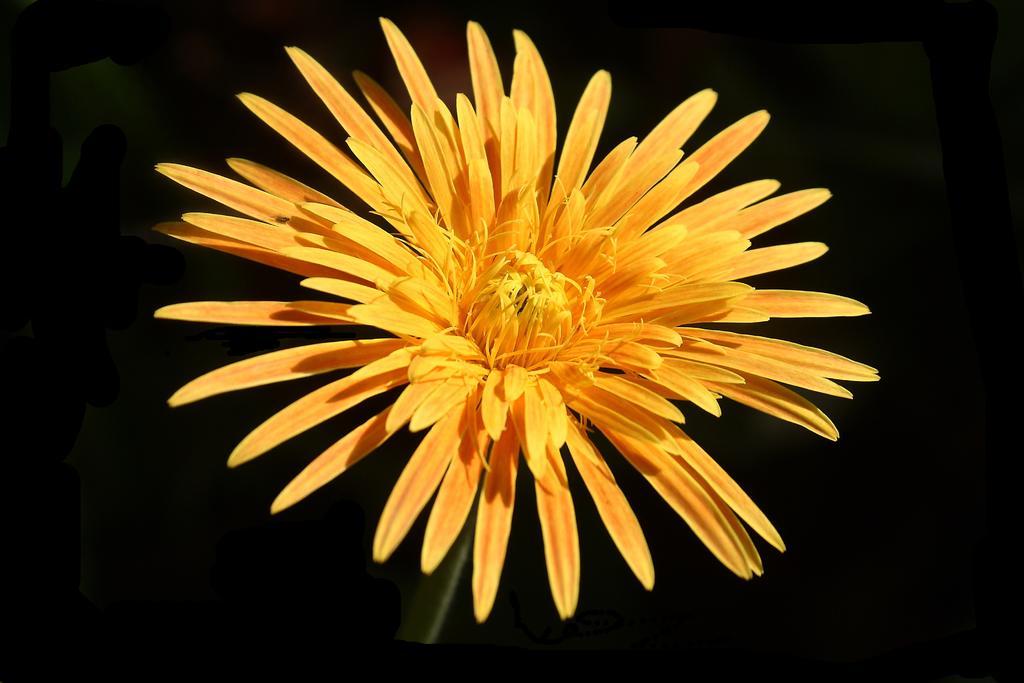Describe this image in one or two sentences. In the image there is a yellow flower and the background of the flower is blue. 